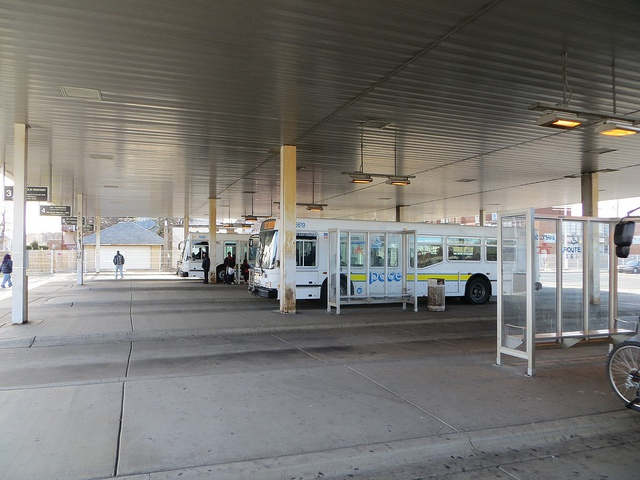Describe the objects in this image and their specific colors. I can see bus in gray, darkgray, and black tones, bus in gray, darkgray, black, and lightgray tones, bicycle in gray, black, and darkgray tones, people in gray, purple, lightgray, and darkgray tones, and people in gray, black, maroon, and darkgreen tones in this image. 